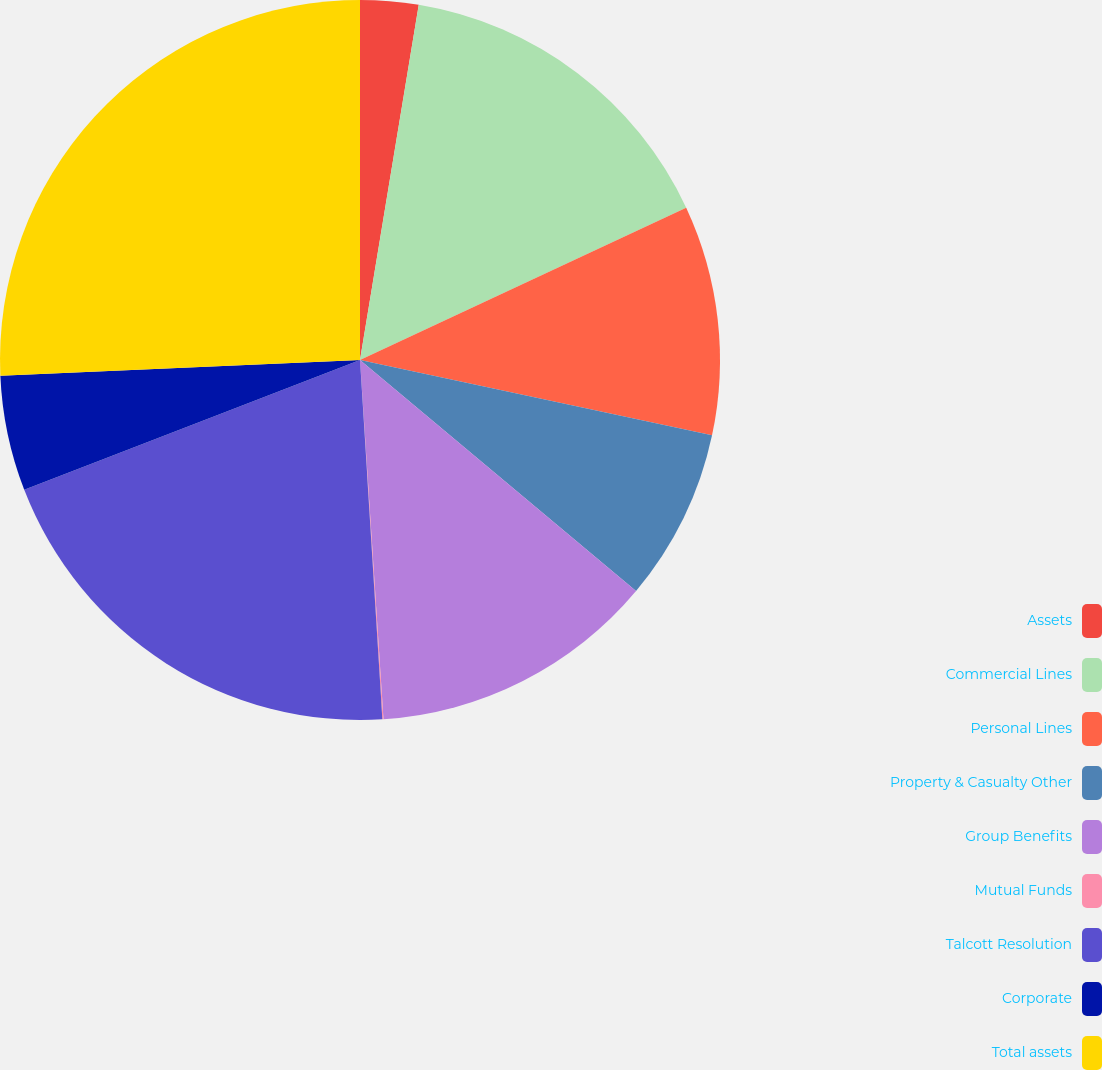<chart> <loc_0><loc_0><loc_500><loc_500><pie_chart><fcel>Assets<fcel>Commercial Lines<fcel>Personal Lines<fcel>Property & Casualty Other<fcel>Group Benefits<fcel>Mutual Funds<fcel>Talcott Resolution<fcel>Corporate<fcel>Total assets<nl><fcel>2.61%<fcel>15.44%<fcel>10.31%<fcel>7.74%<fcel>12.87%<fcel>0.05%<fcel>20.12%<fcel>5.18%<fcel>25.7%<nl></chart> 